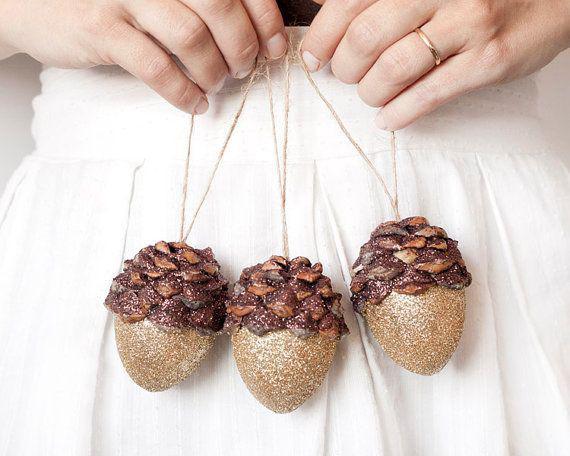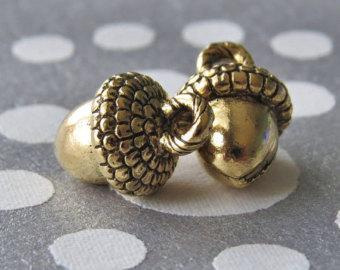The first image is the image on the left, the second image is the image on the right. For the images shown, is this caption "The left and right image contains a total of five arons." true? Answer yes or no. Yes. 